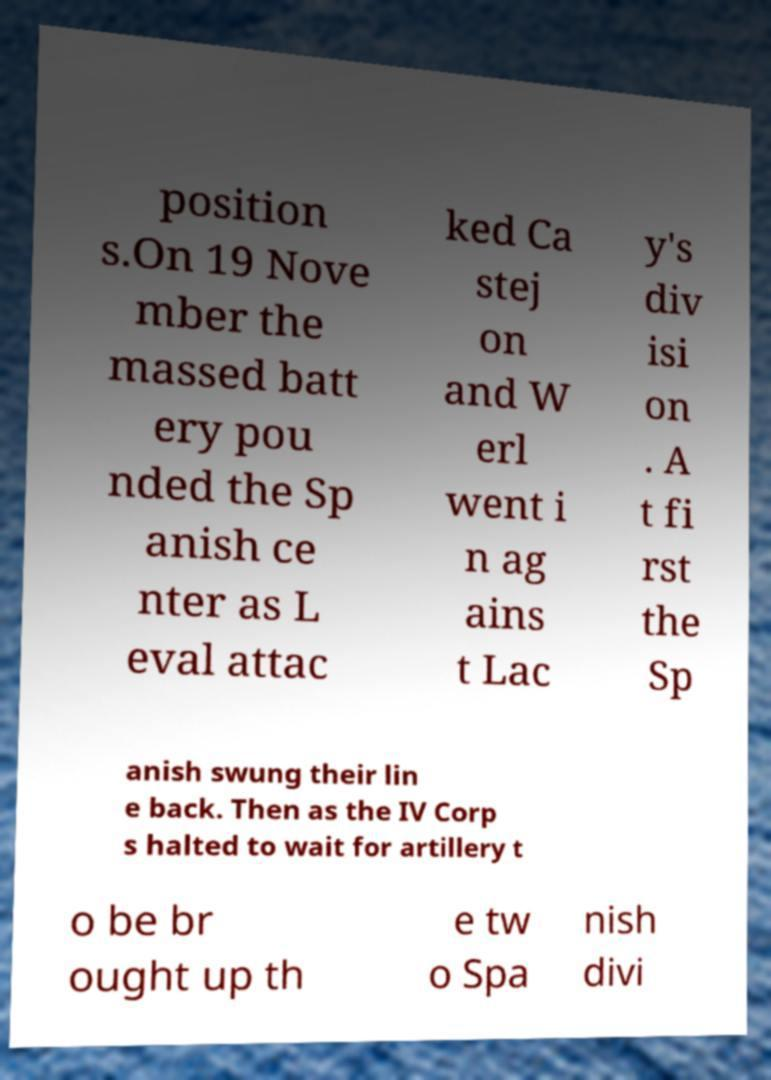Please read and relay the text visible in this image. What does it say? position s.On 19 Nove mber the massed batt ery pou nded the Sp anish ce nter as L eval attac ked Ca stej on and W erl went i n ag ains t Lac y's div isi on . A t fi rst the Sp anish swung their lin e back. Then as the IV Corp s halted to wait for artillery t o be br ought up th e tw o Spa nish divi 